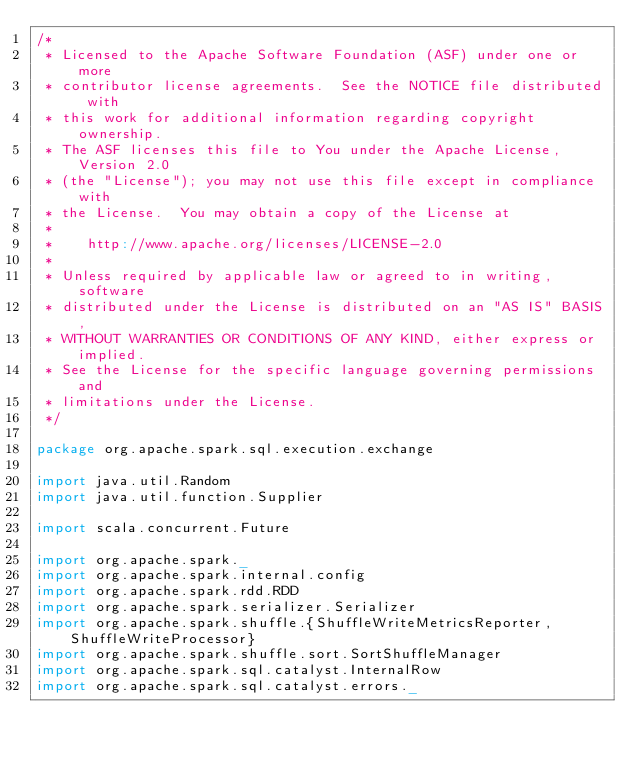<code> <loc_0><loc_0><loc_500><loc_500><_Scala_>/*
 * Licensed to the Apache Software Foundation (ASF) under one or more
 * contributor license agreements.  See the NOTICE file distributed with
 * this work for additional information regarding copyright ownership.
 * The ASF licenses this file to You under the Apache License, Version 2.0
 * (the "License"); you may not use this file except in compliance with
 * the License.  You may obtain a copy of the License at
 *
 *    http://www.apache.org/licenses/LICENSE-2.0
 *
 * Unless required by applicable law or agreed to in writing, software
 * distributed under the License is distributed on an "AS IS" BASIS,
 * WITHOUT WARRANTIES OR CONDITIONS OF ANY KIND, either express or implied.
 * See the License for the specific language governing permissions and
 * limitations under the License.
 */

package org.apache.spark.sql.execution.exchange

import java.util.Random
import java.util.function.Supplier

import scala.concurrent.Future

import org.apache.spark._
import org.apache.spark.internal.config
import org.apache.spark.rdd.RDD
import org.apache.spark.serializer.Serializer
import org.apache.spark.shuffle.{ShuffleWriteMetricsReporter, ShuffleWriteProcessor}
import org.apache.spark.shuffle.sort.SortShuffleManager
import org.apache.spark.sql.catalyst.InternalRow
import org.apache.spark.sql.catalyst.errors._</code> 